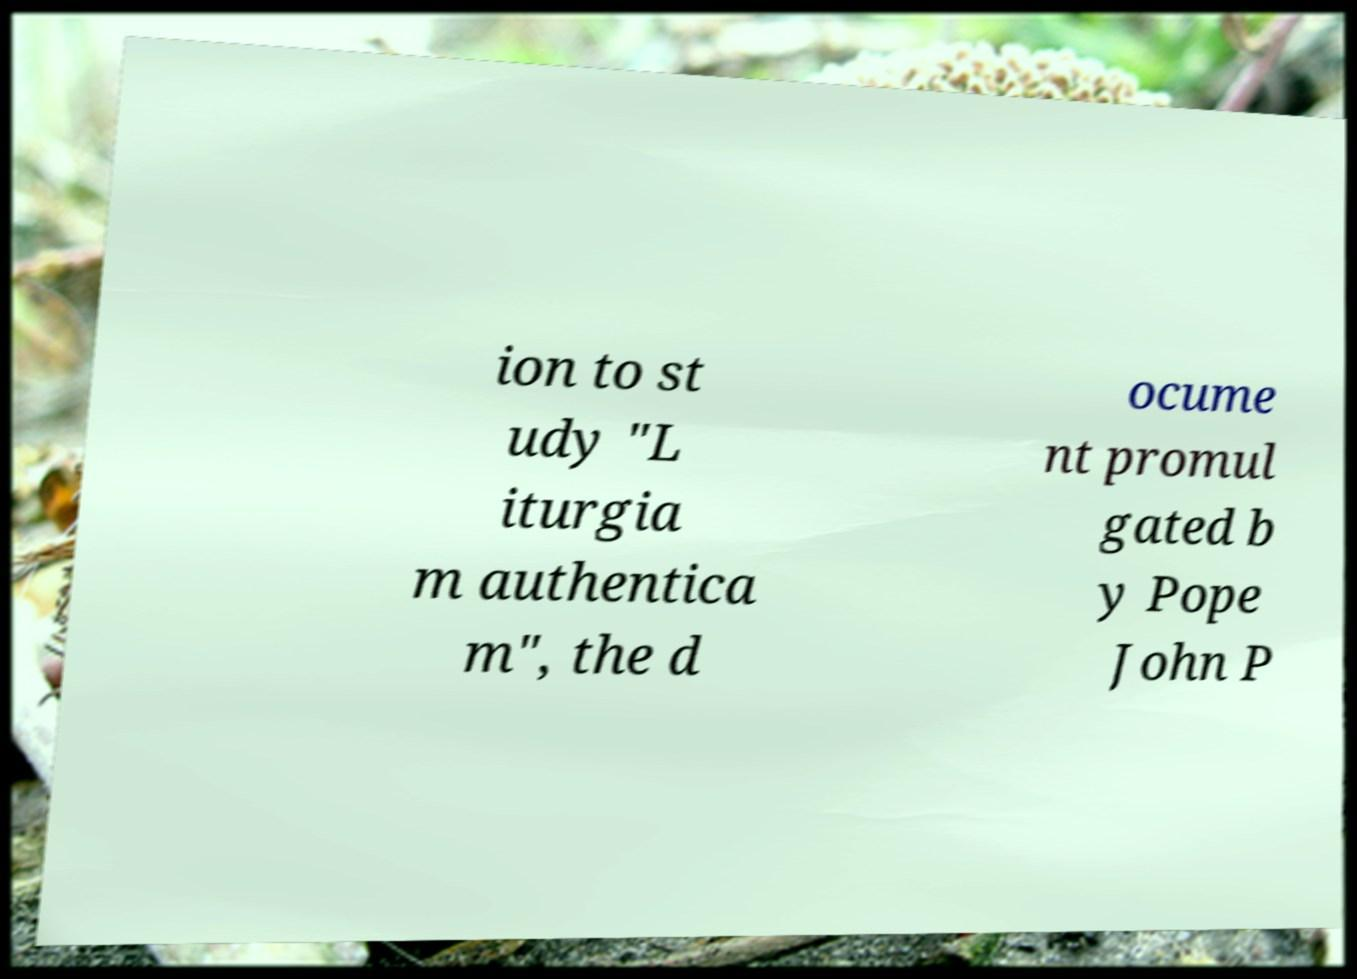For documentation purposes, I need the text within this image transcribed. Could you provide that? ion to st udy "L iturgia m authentica m", the d ocume nt promul gated b y Pope John P 